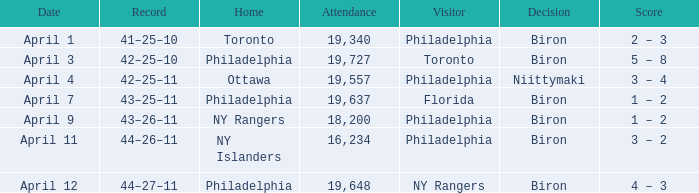What was the flyers' record when the visitors were florida? 43–25–11. 